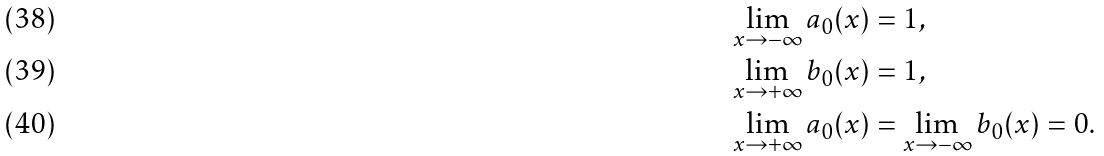Convert formula to latex. <formula><loc_0><loc_0><loc_500><loc_500>\lim _ { x \rightarrow - \infty } a _ { 0 } ( x ) & = 1 , \\ \lim _ { x \rightarrow + \infty } b _ { 0 } ( x ) & = 1 , \\ \lim _ { x \rightarrow + \infty } a _ { 0 } ( x ) & = \lim _ { x \rightarrow - \infty } b _ { 0 } ( x ) = 0 .</formula> 